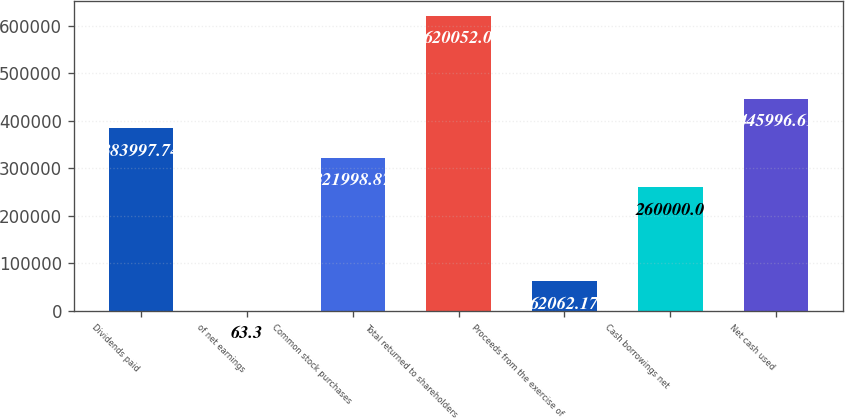Convert chart to OTSL. <chart><loc_0><loc_0><loc_500><loc_500><bar_chart><fcel>Dividends paid<fcel>of net earnings<fcel>Common stock purchases<fcel>Total returned to shareholders<fcel>Proceeds from the exercise of<fcel>Cash borrowings net<fcel>Net cash used<nl><fcel>383998<fcel>63.3<fcel>321999<fcel>620052<fcel>62062.2<fcel>260000<fcel>445997<nl></chart> 